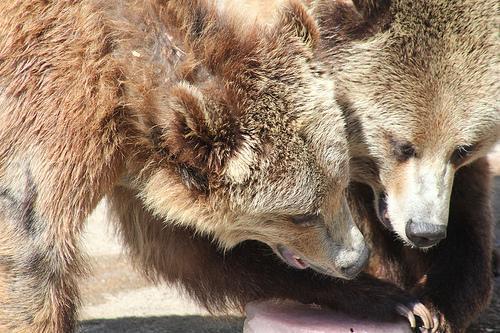How many animals are pictured?
Give a very brief answer. 2. 